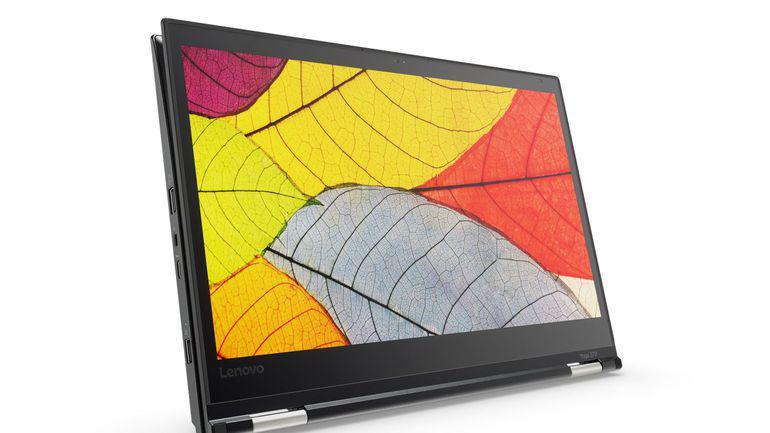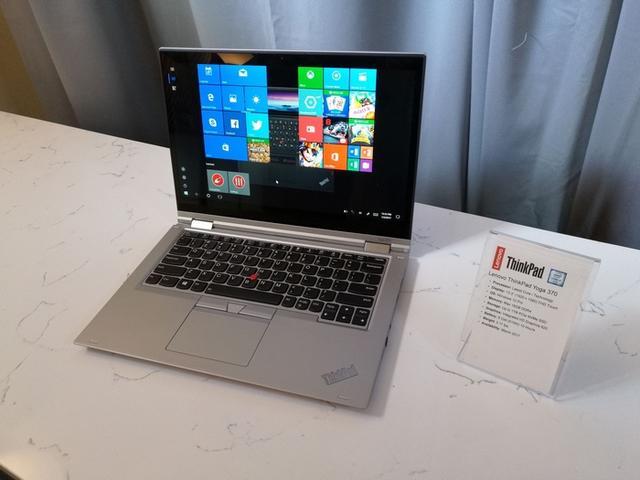The first image is the image on the left, the second image is the image on the right. For the images displayed, is the sentence "Each image shows an open tablet laptop sitting flat on its keyboard base, with a picture on its screen, and at least one image shows the screen reversed so the picture is on the back." factually correct? Answer yes or no. No. The first image is the image on the left, the second image is the image on the right. For the images shown, is this caption "Every laptop is shown on a solid white background." true? Answer yes or no. No. 